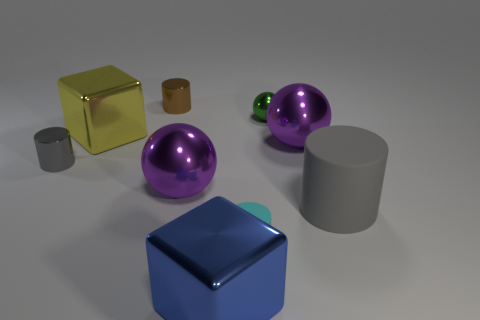Is there anything else that is the same color as the large matte thing?
Provide a succinct answer. Yes. There is a object that is on the right side of the tiny green shiny thing and to the left of the big gray cylinder; what is its size?
Provide a succinct answer. Large. Do the large rubber object and the tiny cylinder that is to the left of the tiny brown metal thing have the same color?
Your answer should be compact. Yes. How many yellow things are small objects or big balls?
Your response must be concise. 0. What shape is the gray metallic object?
Your answer should be very brief. Cylinder. What number of other things are the same shape as the small matte object?
Keep it short and to the point. 3. What color is the small metal object that is in front of the small ball?
Your answer should be compact. Gray. Is the large blue block made of the same material as the large cylinder?
Give a very brief answer. No. How many objects are big blue metallic objects or tiny cylinders that are behind the cyan matte object?
Give a very brief answer. 3. The large purple object on the right side of the cyan matte cylinder has what shape?
Give a very brief answer. Sphere. 